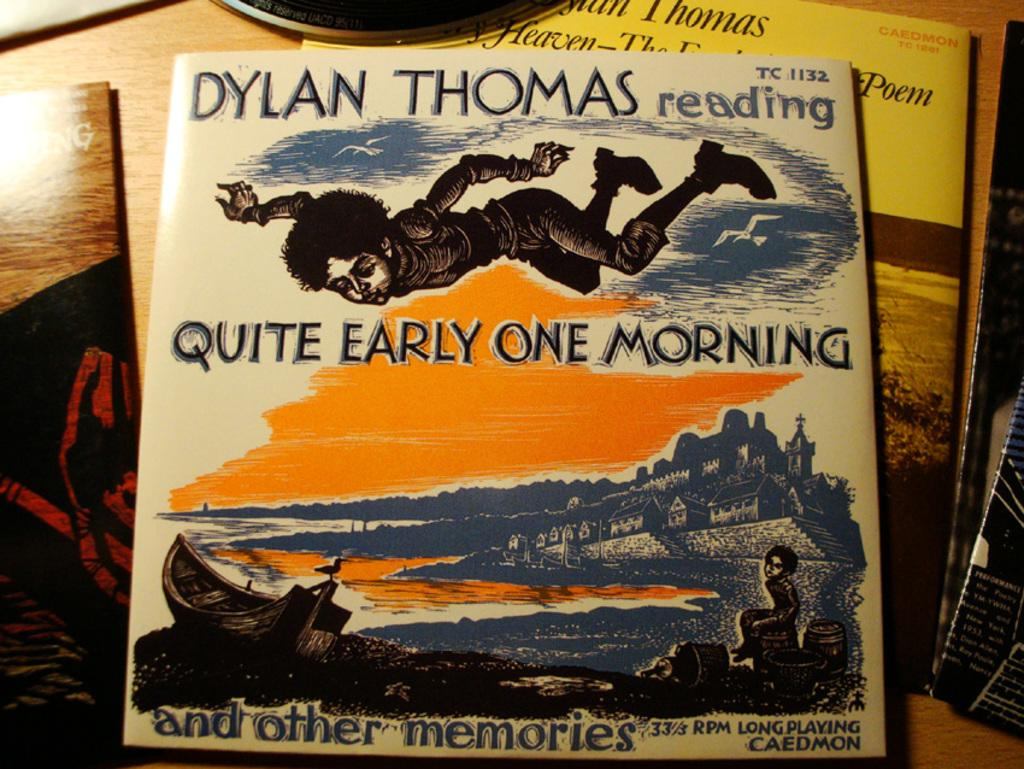What objects are on the table in the image? There are books on the table in the image. What might the books be used for? The books might be used for reading or studying. How many books are visible on the table? The number of books visible on the table cannot be determined from the provided fact. What type of connection can be seen between the books and the fairies in the image? There are no fairies present in the image, and therefore no connection between the books and fairies can be observed. 